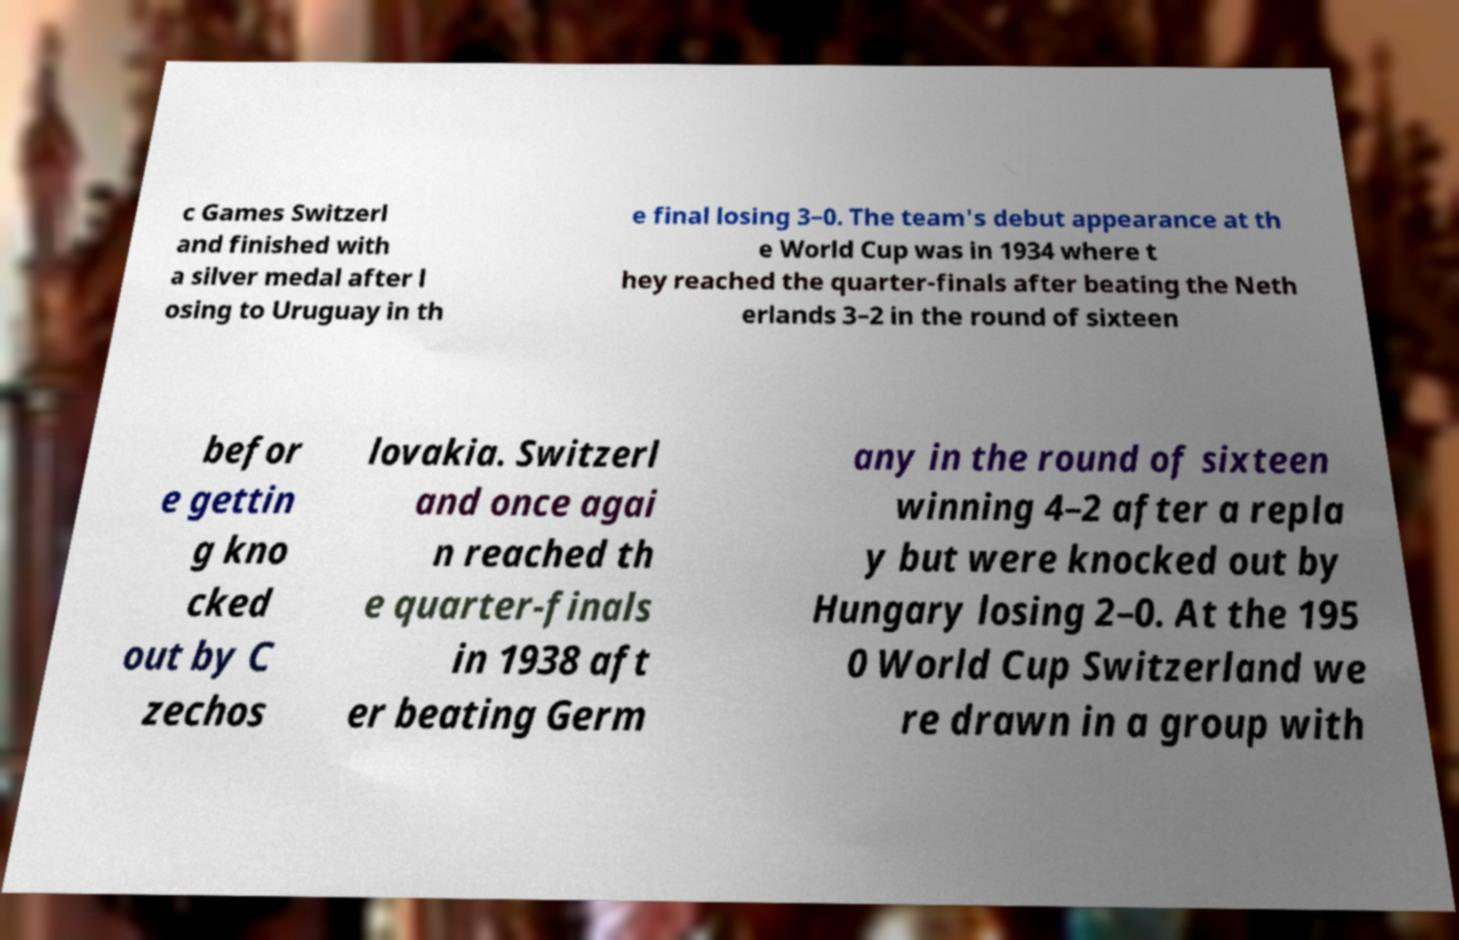There's text embedded in this image that I need extracted. Can you transcribe it verbatim? c Games Switzerl and finished with a silver medal after l osing to Uruguay in th e final losing 3–0. The team's debut appearance at th e World Cup was in 1934 where t hey reached the quarter-finals after beating the Neth erlands 3–2 in the round of sixteen befor e gettin g kno cked out by C zechos lovakia. Switzerl and once agai n reached th e quarter-finals in 1938 aft er beating Germ any in the round of sixteen winning 4–2 after a repla y but were knocked out by Hungary losing 2–0. At the 195 0 World Cup Switzerland we re drawn in a group with 